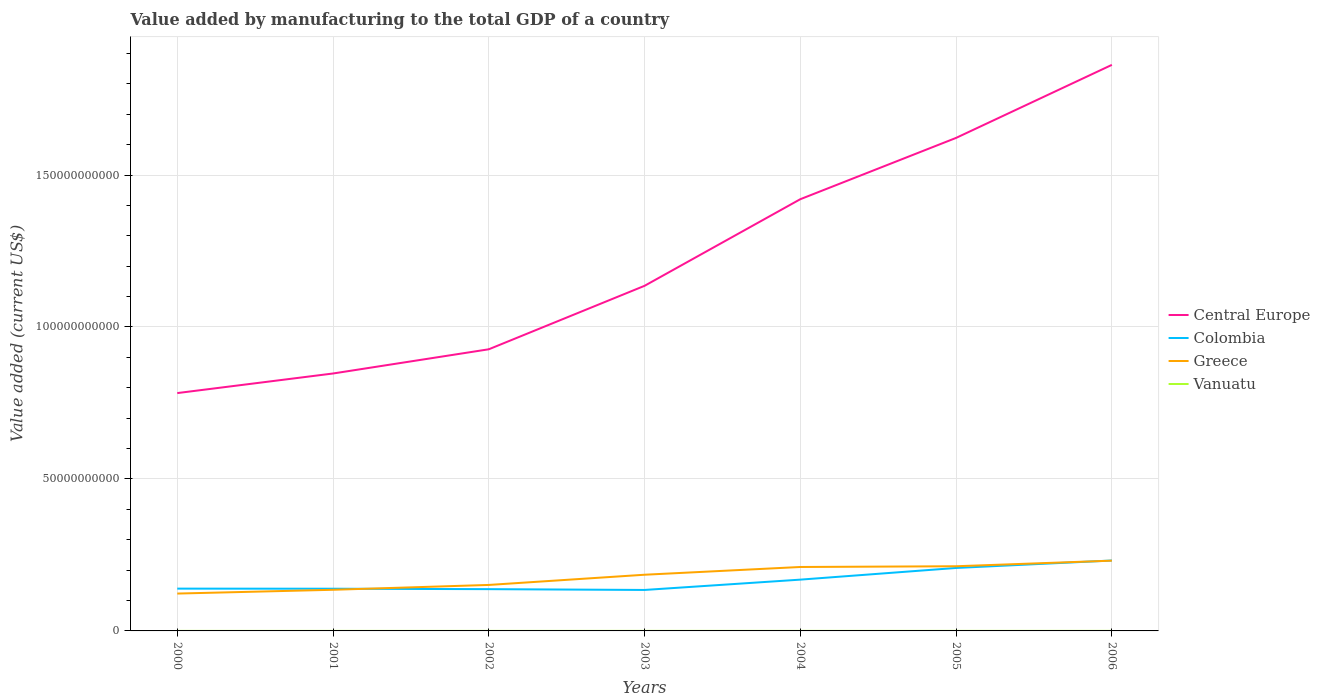How many different coloured lines are there?
Your answer should be very brief. 4. Across all years, what is the maximum value added by manufacturing to the total GDP in Central Europe?
Make the answer very short. 7.82e+1. In which year was the value added by manufacturing to the total GDP in Central Europe maximum?
Ensure brevity in your answer.  2000. What is the total value added by manufacturing to the total GDP in Central Europe in the graph?
Ensure brevity in your answer.  -4.87e+1. What is the difference between the highest and the second highest value added by manufacturing to the total GDP in Vanuatu?
Your response must be concise. 4.83e+06. What is the difference between the highest and the lowest value added by manufacturing to the total GDP in Vanuatu?
Provide a succinct answer. 3. Is the value added by manufacturing to the total GDP in Greece strictly greater than the value added by manufacturing to the total GDP in Central Europe over the years?
Your response must be concise. Yes. How many lines are there?
Make the answer very short. 4. Are the values on the major ticks of Y-axis written in scientific E-notation?
Offer a very short reply. No. How many legend labels are there?
Offer a terse response. 4. What is the title of the graph?
Your answer should be compact. Value added by manufacturing to the total GDP of a country. What is the label or title of the X-axis?
Give a very brief answer. Years. What is the label or title of the Y-axis?
Give a very brief answer. Value added (current US$). What is the Value added (current US$) of Central Europe in 2000?
Provide a short and direct response. 7.82e+1. What is the Value added (current US$) of Colombia in 2000?
Ensure brevity in your answer.  1.39e+1. What is the Value added (current US$) in Greece in 2000?
Ensure brevity in your answer.  1.23e+1. What is the Value added (current US$) of Vanuatu in 2000?
Your response must be concise. 1.23e+07. What is the Value added (current US$) of Central Europe in 2001?
Your answer should be very brief. 8.47e+1. What is the Value added (current US$) in Colombia in 2001?
Ensure brevity in your answer.  1.39e+1. What is the Value added (current US$) of Greece in 2001?
Provide a succinct answer. 1.35e+1. What is the Value added (current US$) in Vanuatu in 2001?
Offer a very short reply. 1.16e+07. What is the Value added (current US$) of Central Europe in 2002?
Offer a very short reply. 9.27e+1. What is the Value added (current US$) in Colombia in 2002?
Provide a short and direct response. 1.37e+1. What is the Value added (current US$) of Greece in 2002?
Provide a short and direct response. 1.51e+1. What is the Value added (current US$) of Vanuatu in 2002?
Your answer should be compact. 1.10e+07. What is the Value added (current US$) in Central Europe in 2003?
Your answer should be very brief. 1.14e+11. What is the Value added (current US$) of Colombia in 2003?
Give a very brief answer. 1.35e+1. What is the Value added (current US$) of Greece in 2003?
Your answer should be very brief. 1.85e+1. What is the Value added (current US$) in Vanuatu in 2003?
Provide a succinct answer. 1.29e+07. What is the Value added (current US$) of Central Europe in 2004?
Provide a short and direct response. 1.42e+11. What is the Value added (current US$) in Colombia in 2004?
Provide a succinct answer. 1.69e+1. What is the Value added (current US$) of Greece in 2004?
Offer a terse response. 2.10e+1. What is the Value added (current US$) in Vanuatu in 2004?
Offer a terse response. 1.47e+07. What is the Value added (current US$) of Central Europe in 2005?
Offer a terse response. 1.62e+11. What is the Value added (current US$) in Colombia in 2005?
Your answer should be very brief. 2.07e+1. What is the Value added (current US$) in Greece in 2005?
Provide a short and direct response. 2.13e+1. What is the Value added (current US$) of Vanuatu in 2005?
Offer a very short reply. 1.50e+07. What is the Value added (current US$) of Central Europe in 2006?
Provide a short and direct response. 1.86e+11. What is the Value added (current US$) of Colombia in 2006?
Your answer should be very brief. 2.32e+1. What is the Value added (current US$) of Greece in 2006?
Provide a succinct answer. 2.31e+1. What is the Value added (current US$) in Vanuatu in 2006?
Offer a very short reply. 1.59e+07. Across all years, what is the maximum Value added (current US$) of Central Europe?
Provide a succinct answer. 1.86e+11. Across all years, what is the maximum Value added (current US$) of Colombia?
Provide a short and direct response. 2.32e+1. Across all years, what is the maximum Value added (current US$) of Greece?
Ensure brevity in your answer.  2.31e+1. Across all years, what is the maximum Value added (current US$) in Vanuatu?
Ensure brevity in your answer.  1.59e+07. Across all years, what is the minimum Value added (current US$) in Central Europe?
Your answer should be compact. 7.82e+1. Across all years, what is the minimum Value added (current US$) in Colombia?
Offer a very short reply. 1.35e+1. Across all years, what is the minimum Value added (current US$) of Greece?
Offer a very short reply. 1.23e+1. Across all years, what is the minimum Value added (current US$) in Vanuatu?
Give a very brief answer. 1.10e+07. What is the total Value added (current US$) in Central Europe in the graph?
Make the answer very short. 8.60e+11. What is the total Value added (current US$) in Colombia in the graph?
Your response must be concise. 1.16e+11. What is the total Value added (current US$) in Greece in the graph?
Make the answer very short. 1.25e+11. What is the total Value added (current US$) in Vanuatu in the graph?
Your response must be concise. 9.34e+07. What is the difference between the Value added (current US$) of Central Europe in 2000 and that in 2001?
Your answer should be very brief. -6.45e+09. What is the difference between the Value added (current US$) of Colombia in 2000 and that in 2001?
Offer a terse response. 3.37e+07. What is the difference between the Value added (current US$) of Greece in 2000 and that in 2001?
Make the answer very short. -1.24e+09. What is the difference between the Value added (current US$) in Vanuatu in 2000 and that in 2001?
Make the answer very short. 6.82e+05. What is the difference between the Value added (current US$) in Central Europe in 2000 and that in 2002?
Give a very brief answer. -1.44e+1. What is the difference between the Value added (current US$) of Colombia in 2000 and that in 2002?
Keep it short and to the point. 1.74e+08. What is the difference between the Value added (current US$) in Greece in 2000 and that in 2002?
Provide a succinct answer. -2.84e+09. What is the difference between the Value added (current US$) of Vanuatu in 2000 and that in 2002?
Keep it short and to the point. 1.24e+06. What is the difference between the Value added (current US$) in Central Europe in 2000 and that in 2003?
Your answer should be compact. -3.53e+1. What is the difference between the Value added (current US$) of Colombia in 2000 and that in 2003?
Provide a succinct answer. 4.36e+08. What is the difference between the Value added (current US$) of Greece in 2000 and that in 2003?
Ensure brevity in your answer.  -6.19e+09. What is the difference between the Value added (current US$) in Vanuatu in 2000 and that in 2003?
Give a very brief answer. -6.28e+05. What is the difference between the Value added (current US$) of Central Europe in 2000 and that in 2004?
Your answer should be very brief. -6.38e+1. What is the difference between the Value added (current US$) of Colombia in 2000 and that in 2004?
Provide a short and direct response. -2.96e+09. What is the difference between the Value added (current US$) in Greece in 2000 and that in 2004?
Your answer should be compact. -8.74e+09. What is the difference between the Value added (current US$) in Vanuatu in 2000 and that in 2004?
Your answer should be very brief. -2.45e+06. What is the difference between the Value added (current US$) of Central Europe in 2000 and that in 2005?
Your response must be concise. -8.40e+1. What is the difference between the Value added (current US$) of Colombia in 2000 and that in 2005?
Offer a terse response. -6.80e+09. What is the difference between the Value added (current US$) in Greece in 2000 and that in 2005?
Your answer should be compact. -8.98e+09. What is the difference between the Value added (current US$) in Vanuatu in 2000 and that in 2005?
Your answer should be very brief. -2.72e+06. What is the difference between the Value added (current US$) of Central Europe in 2000 and that in 2006?
Give a very brief answer. -1.08e+11. What is the difference between the Value added (current US$) of Colombia in 2000 and that in 2006?
Provide a succinct answer. -9.25e+09. What is the difference between the Value added (current US$) of Greece in 2000 and that in 2006?
Offer a terse response. -1.08e+1. What is the difference between the Value added (current US$) in Vanuatu in 2000 and that in 2006?
Offer a terse response. -3.59e+06. What is the difference between the Value added (current US$) of Central Europe in 2001 and that in 2002?
Make the answer very short. -7.97e+09. What is the difference between the Value added (current US$) in Colombia in 2001 and that in 2002?
Give a very brief answer. 1.40e+08. What is the difference between the Value added (current US$) of Greece in 2001 and that in 2002?
Your answer should be very brief. -1.59e+09. What is the difference between the Value added (current US$) of Vanuatu in 2001 and that in 2002?
Your response must be concise. 5.54e+05. What is the difference between the Value added (current US$) in Central Europe in 2001 and that in 2003?
Provide a short and direct response. -2.88e+1. What is the difference between the Value added (current US$) of Colombia in 2001 and that in 2003?
Your answer should be compact. 4.03e+08. What is the difference between the Value added (current US$) of Greece in 2001 and that in 2003?
Provide a short and direct response. -4.95e+09. What is the difference between the Value added (current US$) of Vanuatu in 2001 and that in 2003?
Ensure brevity in your answer.  -1.31e+06. What is the difference between the Value added (current US$) in Central Europe in 2001 and that in 2004?
Offer a terse response. -5.73e+1. What is the difference between the Value added (current US$) in Colombia in 2001 and that in 2004?
Make the answer very short. -2.99e+09. What is the difference between the Value added (current US$) of Greece in 2001 and that in 2004?
Provide a short and direct response. -7.50e+09. What is the difference between the Value added (current US$) in Vanuatu in 2001 and that in 2004?
Offer a very short reply. -3.13e+06. What is the difference between the Value added (current US$) in Central Europe in 2001 and that in 2005?
Your answer should be very brief. -7.75e+1. What is the difference between the Value added (current US$) of Colombia in 2001 and that in 2005?
Provide a short and direct response. -6.83e+09. What is the difference between the Value added (current US$) of Greece in 2001 and that in 2005?
Your response must be concise. -7.74e+09. What is the difference between the Value added (current US$) in Vanuatu in 2001 and that in 2005?
Offer a terse response. -3.41e+06. What is the difference between the Value added (current US$) of Central Europe in 2001 and that in 2006?
Offer a terse response. -1.02e+11. What is the difference between the Value added (current US$) of Colombia in 2001 and that in 2006?
Provide a short and direct response. -9.29e+09. What is the difference between the Value added (current US$) in Greece in 2001 and that in 2006?
Offer a terse response. -9.58e+09. What is the difference between the Value added (current US$) in Vanuatu in 2001 and that in 2006?
Your response must be concise. -4.28e+06. What is the difference between the Value added (current US$) of Central Europe in 2002 and that in 2003?
Offer a very short reply. -2.09e+1. What is the difference between the Value added (current US$) of Colombia in 2002 and that in 2003?
Your response must be concise. 2.62e+08. What is the difference between the Value added (current US$) in Greece in 2002 and that in 2003?
Ensure brevity in your answer.  -3.36e+09. What is the difference between the Value added (current US$) in Vanuatu in 2002 and that in 2003?
Your answer should be very brief. -1.86e+06. What is the difference between the Value added (current US$) of Central Europe in 2002 and that in 2004?
Give a very brief answer. -4.94e+1. What is the difference between the Value added (current US$) of Colombia in 2002 and that in 2004?
Offer a very short reply. -3.13e+09. What is the difference between the Value added (current US$) of Greece in 2002 and that in 2004?
Offer a very short reply. -5.91e+09. What is the difference between the Value added (current US$) in Vanuatu in 2002 and that in 2004?
Provide a short and direct response. -3.68e+06. What is the difference between the Value added (current US$) of Central Europe in 2002 and that in 2005?
Keep it short and to the point. -6.95e+1. What is the difference between the Value added (current US$) of Colombia in 2002 and that in 2005?
Make the answer very short. -6.97e+09. What is the difference between the Value added (current US$) of Greece in 2002 and that in 2005?
Your answer should be very brief. -6.15e+09. What is the difference between the Value added (current US$) of Vanuatu in 2002 and that in 2005?
Offer a terse response. -3.96e+06. What is the difference between the Value added (current US$) of Central Europe in 2002 and that in 2006?
Your answer should be very brief. -9.36e+1. What is the difference between the Value added (current US$) in Colombia in 2002 and that in 2006?
Keep it short and to the point. -9.43e+09. What is the difference between the Value added (current US$) in Greece in 2002 and that in 2006?
Offer a very short reply. -7.99e+09. What is the difference between the Value added (current US$) of Vanuatu in 2002 and that in 2006?
Offer a terse response. -4.83e+06. What is the difference between the Value added (current US$) of Central Europe in 2003 and that in 2004?
Give a very brief answer. -2.85e+1. What is the difference between the Value added (current US$) of Colombia in 2003 and that in 2004?
Your answer should be very brief. -3.39e+09. What is the difference between the Value added (current US$) of Greece in 2003 and that in 2004?
Keep it short and to the point. -2.55e+09. What is the difference between the Value added (current US$) in Vanuatu in 2003 and that in 2004?
Your response must be concise. -1.82e+06. What is the difference between the Value added (current US$) in Central Europe in 2003 and that in 2005?
Offer a very short reply. -4.87e+1. What is the difference between the Value added (current US$) of Colombia in 2003 and that in 2005?
Your answer should be compact. -7.24e+09. What is the difference between the Value added (current US$) in Greece in 2003 and that in 2005?
Provide a short and direct response. -2.79e+09. What is the difference between the Value added (current US$) of Vanuatu in 2003 and that in 2005?
Your answer should be compact. -2.10e+06. What is the difference between the Value added (current US$) of Central Europe in 2003 and that in 2006?
Your response must be concise. -7.27e+1. What is the difference between the Value added (current US$) of Colombia in 2003 and that in 2006?
Offer a very short reply. -9.69e+09. What is the difference between the Value added (current US$) of Greece in 2003 and that in 2006?
Your answer should be compact. -4.63e+09. What is the difference between the Value added (current US$) of Vanuatu in 2003 and that in 2006?
Make the answer very short. -2.96e+06. What is the difference between the Value added (current US$) in Central Europe in 2004 and that in 2005?
Give a very brief answer. -2.02e+1. What is the difference between the Value added (current US$) in Colombia in 2004 and that in 2005?
Ensure brevity in your answer.  -3.84e+09. What is the difference between the Value added (current US$) of Greece in 2004 and that in 2005?
Ensure brevity in your answer.  -2.39e+08. What is the difference between the Value added (current US$) in Vanuatu in 2004 and that in 2005?
Provide a succinct answer. -2.79e+05. What is the difference between the Value added (current US$) of Central Europe in 2004 and that in 2006?
Offer a terse response. -4.42e+1. What is the difference between the Value added (current US$) of Colombia in 2004 and that in 2006?
Offer a very short reply. -6.29e+09. What is the difference between the Value added (current US$) of Greece in 2004 and that in 2006?
Your response must be concise. -2.08e+09. What is the difference between the Value added (current US$) of Vanuatu in 2004 and that in 2006?
Provide a succinct answer. -1.15e+06. What is the difference between the Value added (current US$) of Central Europe in 2005 and that in 2006?
Make the answer very short. -2.40e+1. What is the difference between the Value added (current US$) in Colombia in 2005 and that in 2006?
Offer a very short reply. -2.45e+09. What is the difference between the Value added (current US$) in Greece in 2005 and that in 2006?
Offer a terse response. -1.84e+09. What is the difference between the Value added (current US$) in Vanuatu in 2005 and that in 2006?
Give a very brief answer. -8.68e+05. What is the difference between the Value added (current US$) of Central Europe in 2000 and the Value added (current US$) of Colombia in 2001?
Make the answer very short. 6.44e+1. What is the difference between the Value added (current US$) in Central Europe in 2000 and the Value added (current US$) in Greece in 2001?
Ensure brevity in your answer.  6.47e+1. What is the difference between the Value added (current US$) of Central Europe in 2000 and the Value added (current US$) of Vanuatu in 2001?
Make the answer very short. 7.82e+1. What is the difference between the Value added (current US$) of Colombia in 2000 and the Value added (current US$) of Greece in 2001?
Make the answer very short. 3.81e+08. What is the difference between the Value added (current US$) of Colombia in 2000 and the Value added (current US$) of Vanuatu in 2001?
Provide a short and direct response. 1.39e+1. What is the difference between the Value added (current US$) of Greece in 2000 and the Value added (current US$) of Vanuatu in 2001?
Make the answer very short. 1.23e+1. What is the difference between the Value added (current US$) in Central Europe in 2000 and the Value added (current US$) in Colombia in 2002?
Offer a very short reply. 6.45e+1. What is the difference between the Value added (current US$) in Central Europe in 2000 and the Value added (current US$) in Greece in 2002?
Your answer should be very brief. 6.31e+1. What is the difference between the Value added (current US$) of Central Europe in 2000 and the Value added (current US$) of Vanuatu in 2002?
Your answer should be very brief. 7.82e+1. What is the difference between the Value added (current US$) of Colombia in 2000 and the Value added (current US$) of Greece in 2002?
Keep it short and to the point. -1.21e+09. What is the difference between the Value added (current US$) of Colombia in 2000 and the Value added (current US$) of Vanuatu in 2002?
Your answer should be compact. 1.39e+1. What is the difference between the Value added (current US$) in Greece in 2000 and the Value added (current US$) in Vanuatu in 2002?
Your answer should be compact. 1.23e+1. What is the difference between the Value added (current US$) in Central Europe in 2000 and the Value added (current US$) in Colombia in 2003?
Your answer should be very brief. 6.48e+1. What is the difference between the Value added (current US$) of Central Europe in 2000 and the Value added (current US$) of Greece in 2003?
Give a very brief answer. 5.98e+1. What is the difference between the Value added (current US$) in Central Europe in 2000 and the Value added (current US$) in Vanuatu in 2003?
Your answer should be compact. 7.82e+1. What is the difference between the Value added (current US$) of Colombia in 2000 and the Value added (current US$) of Greece in 2003?
Offer a terse response. -4.57e+09. What is the difference between the Value added (current US$) of Colombia in 2000 and the Value added (current US$) of Vanuatu in 2003?
Your answer should be compact. 1.39e+1. What is the difference between the Value added (current US$) in Greece in 2000 and the Value added (current US$) in Vanuatu in 2003?
Your response must be concise. 1.23e+1. What is the difference between the Value added (current US$) in Central Europe in 2000 and the Value added (current US$) in Colombia in 2004?
Make the answer very short. 6.14e+1. What is the difference between the Value added (current US$) in Central Europe in 2000 and the Value added (current US$) in Greece in 2004?
Provide a succinct answer. 5.72e+1. What is the difference between the Value added (current US$) of Central Europe in 2000 and the Value added (current US$) of Vanuatu in 2004?
Give a very brief answer. 7.82e+1. What is the difference between the Value added (current US$) of Colombia in 2000 and the Value added (current US$) of Greece in 2004?
Ensure brevity in your answer.  -7.12e+09. What is the difference between the Value added (current US$) of Colombia in 2000 and the Value added (current US$) of Vanuatu in 2004?
Your answer should be compact. 1.39e+1. What is the difference between the Value added (current US$) of Greece in 2000 and the Value added (current US$) of Vanuatu in 2004?
Offer a very short reply. 1.23e+1. What is the difference between the Value added (current US$) of Central Europe in 2000 and the Value added (current US$) of Colombia in 2005?
Your response must be concise. 5.75e+1. What is the difference between the Value added (current US$) in Central Europe in 2000 and the Value added (current US$) in Greece in 2005?
Keep it short and to the point. 5.70e+1. What is the difference between the Value added (current US$) of Central Europe in 2000 and the Value added (current US$) of Vanuatu in 2005?
Ensure brevity in your answer.  7.82e+1. What is the difference between the Value added (current US$) of Colombia in 2000 and the Value added (current US$) of Greece in 2005?
Keep it short and to the point. -7.36e+09. What is the difference between the Value added (current US$) of Colombia in 2000 and the Value added (current US$) of Vanuatu in 2005?
Ensure brevity in your answer.  1.39e+1. What is the difference between the Value added (current US$) of Greece in 2000 and the Value added (current US$) of Vanuatu in 2005?
Provide a succinct answer. 1.23e+1. What is the difference between the Value added (current US$) in Central Europe in 2000 and the Value added (current US$) in Colombia in 2006?
Offer a very short reply. 5.51e+1. What is the difference between the Value added (current US$) of Central Europe in 2000 and the Value added (current US$) of Greece in 2006?
Keep it short and to the point. 5.51e+1. What is the difference between the Value added (current US$) of Central Europe in 2000 and the Value added (current US$) of Vanuatu in 2006?
Give a very brief answer. 7.82e+1. What is the difference between the Value added (current US$) of Colombia in 2000 and the Value added (current US$) of Greece in 2006?
Your answer should be compact. -9.20e+09. What is the difference between the Value added (current US$) of Colombia in 2000 and the Value added (current US$) of Vanuatu in 2006?
Keep it short and to the point. 1.39e+1. What is the difference between the Value added (current US$) of Greece in 2000 and the Value added (current US$) of Vanuatu in 2006?
Your response must be concise. 1.23e+1. What is the difference between the Value added (current US$) in Central Europe in 2001 and the Value added (current US$) in Colombia in 2002?
Give a very brief answer. 7.10e+1. What is the difference between the Value added (current US$) of Central Europe in 2001 and the Value added (current US$) of Greece in 2002?
Keep it short and to the point. 6.96e+1. What is the difference between the Value added (current US$) in Central Europe in 2001 and the Value added (current US$) in Vanuatu in 2002?
Keep it short and to the point. 8.47e+1. What is the difference between the Value added (current US$) of Colombia in 2001 and the Value added (current US$) of Greece in 2002?
Your answer should be compact. -1.25e+09. What is the difference between the Value added (current US$) in Colombia in 2001 and the Value added (current US$) in Vanuatu in 2002?
Provide a succinct answer. 1.39e+1. What is the difference between the Value added (current US$) of Greece in 2001 and the Value added (current US$) of Vanuatu in 2002?
Provide a succinct answer. 1.35e+1. What is the difference between the Value added (current US$) in Central Europe in 2001 and the Value added (current US$) in Colombia in 2003?
Your response must be concise. 7.12e+1. What is the difference between the Value added (current US$) in Central Europe in 2001 and the Value added (current US$) in Greece in 2003?
Your response must be concise. 6.62e+1. What is the difference between the Value added (current US$) of Central Europe in 2001 and the Value added (current US$) of Vanuatu in 2003?
Offer a terse response. 8.47e+1. What is the difference between the Value added (current US$) of Colombia in 2001 and the Value added (current US$) of Greece in 2003?
Provide a succinct answer. -4.60e+09. What is the difference between the Value added (current US$) in Colombia in 2001 and the Value added (current US$) in Vanuatu in 2003?
Your response must be concise. 1.39e+1. What is the difference between the Value added (current US$) in Greece in 2001 and the Value added (current US$) in Vanuatu in 2003?
Your answer should be very brief. 1.35e+1. What is the difference between the Value added (current US$) in Central Europe in 2001 and the Value added (current US$) in Colombia in 2004?
Keep it short and to the point. 6.78e+1. What is the difference between the Value added (current US$) in Central Europe in 2001 and the Value added (current US$) in Greece in 2004?
Give a very brief answer. 6.37e+1. What is the difference between the Value added (current US$) of Central Europe in 2001 and the Value added (current US$) of Vanuatu in 2004?
Provide a succinct answer. 8.47e+1. What is the difference between the Value added (current US$) in Colombia in 2001 and the Value added (current US$) in Greece in 2004?
Your answer should be very brief. -7.15e+09. What is the difference between the Value added (current US$) of Colombia in 2001 and the Value added (current US$) of Vanuatu in 2004?
Ensure brevity in your answer.  1.39e+1. What is the difference between the Value added (current US$) of Greece in 2001 and the Value added (current US$) of Vanuatu in 2004?
Give a very brief answer. 1.35e+1. What is the difference between the Value added (current US$) in Central Europe in 2001 and the Value added (current US$) in Colombia in 2005?
Offer a very short reply. 6.40e+1. What is the difference between the Value added (current US$) of Central Europe in 2001 and the Value added (current US$) of Greece in 2005?
Ensure brevity in your answer.  6.34e+1. What is the difference between the Value added (current US$) of Central Europe in 2001 and the Value added (current US$) of Vanuatu in 2005?
Give a very brief answer. 8.47e+1. What is the difference between the Value added (current US$) in Colombia in 2001 and the Value added (current US$) in Greece in 2005?
Provide a short and direct response. -7.39e+09. What is the difference between the Value added (current US$) of Colombia in 2001 and the Value added (current US$) of Vanuatu in 2005?
Offer a terse response. 1.39e+1. What is the difference between the Value added (current US$) in Greece in 2001 and the Value added (current US$) in Vanuatu in 2005?
Offer a terse response. 1.35e+1. What is the difference between the Value added (current US$) in Central Europe in 2001 and the Value added (current US$) in Colombia in 2006?
Your answer should be compact. 6.15e+1. What is the difference between the Value added (current US$) of Central Europe in 2001 and the Value added (current US$) of Greece in 2006?
Your answer should be compact. 6.16e+1. What is the difference between the Value added (current US$) of Central Europe in 2001 and the Value added (current US$) of Vanuatu in 2006?
Give a very brief answer. 8.47e+1. What is the difference between the Value added (current US$) in Colombia in 2001 and the Value added (current US$) in Greece in 2006?
Offer a very short reply. -9.23e+09. What is the difference between the Value added (current US$) of Colombia in 2001 and the Value added (current US$) of Vanuatu in 2006?
Give a very brief answer. 1.39e+1. What is the difference between the Value added (current US$) in Greece in 2001 and the Value added (current US$) in Vanuatu in 2006?
Ensure brevity in your answer.  1.35e+1. What is the difference between the Value added (current US$) in Central Europe in 2002 and the Value added (current US$) in Colombia in 2003?
Your response must be concise. 7.92e+1. What is the difference between the Value added (current US$) of Central Europe in 2002 and the Value added (current US$) of Greece in 2003?
Your answer should be compact. 7.42e+1. What is the difference between the Value added (current US$) of Central Europe in 2002 and the Value added (current US$) of Vanuatu in 2003?
Keep it short and to the point. 9.26e+1. What is the difference between the Value added (current US$) of Colombia in 2002 and the Value added (current US$) of Greece in 2003?
Make the answer very short. -4.74e+09. What is the difference between the Value added (current US$) of Colombia in 2002 and the Value added (current US$) of Vanuatu in 2003?
Your response must be concise. 1.37e+1. What is the difference between the Value added (current US$) of Greece in 2002 and the Value added (current US$) of Vanuatu in 2003?
Keep it short and to the point. 1.51e+1. What is the difference between the Value added (current US$) in Central Europe in 2002 and the Value added (current US$) in Colombia in 2004?
Offer a very short reply. 7.58e+1. What is the difference between the Value added (current US$) of Central Europe in 2002 and the Value added (current US$) of Greece in 2004?
Your response must be concise. 7.16e+1. What is the difference between the Value added (current US$) in Central Europe in 2002 and the Value added (current US$) in Vanuatu in 2004?
Keep it short and to the point. 9.26e+1. What is the difference between the Value added (current US$) in Colombia in 2002 and the Value added (current US$) in Greece in 2004?
Offer a terse response. -7.29e+09. What is the difference between the Value added (current US$) in Colombia in 2002 and the Value added (current US$) in Vanuatu in 2004?
Provide a short and direct response. 1.37e+1. What is the difference between the Value added (current US$) in Greece in 2002 and the Value added (current US$) in Vanuatu in 2004?
Make the answer very short. 1.51e+1. What is the difference between the Value added (current US$) in Central Europe in 2002 and the Value added (current US$) in Colombia in 2005?
Make the answer very short. 7.19e+1. What is the difference between the Value added (current US$) of Central Europe in 2002 and the Value added (current US$) of Greece in 2005?
Make the answer very short. 7.14e+1. What is the difference between the Value added (current US$) of Central Europe in 2002 and the Value added (current US$) of Vanuatu in 2005?
Your answer should be very brief. 9.26e+1. What is the difference between the Value added (current US$) of Colombia in 2002 and the Value added (current US$) of Greece in 2005?
Offer a terse response. -7.53e+09. What is the difference between the Value added (current US$) of Colombia in 2002 and the Value added (current US$) of Vanuatu in 2005?
Provide a succinct answer. 1.37e+1. What is the difference between the Value added (current US$) in Greece in 2002 and the Value added (current US$) in Vanuatu in 2005?
Offer a terse response. 1.51e+1. What is the difference between the Value added (current US$) in Central Europe in 2002 and the Value added (current US$) in Colombia in 2006?
Make the answer very short. 6.95e+1. What is the difference between the Value added (current US$) of Central Europe in 2002 and the Value added (current US$) of Greece in 2006?
Give a very brief answer. 6.95e+1. What is the difference between the Value added (current US$) of Central Europe in 2002 and the Value added (current US$) of Vanuatu in 2006?
Give a very brief answer. 9.26e+1. What is the difference between the Value added (current US$) of Colombia in 2002 and the Value added (current US$) of Greece in 2006?
Provide a short and direct response. -9.37e+09. What is the difference between the Value added (current US$) in Colombia in 2002 and the Value added (current US$) in Vanuatu in 2006?
Ensure brevity in your answer.  1.37e+1. What is the difference between the Value added (current US$) of Greece in 2002 and the Value added (current US$) of Vanuatu in 2006?
Offer a terse response. 1.51e+1. What is the difference between the Value added (current US$) of Central Europe in 2003 and the Value added (current US$) of Colombia in 2004?
Make the answer very short. 9.67e+1. What is the difference between the Value added (current US$) of Central Europe in 2003 and the Value added (current US$) of Greece in 2004?
Your response must be concise. 9.25e+1. What is the difference between the Value added (current US$) of Central Europe in 2003 and the Value added (current US$) of Vanuatu in 2004?
Give a very brief answer. 1.14e+11. What is the difference between the Value added (current US$) of Colombia in 2003 and the Value added (current US$) of Greece in 2004?
Your answer should be compact. -7.56e+09. What is the difference between the Value added (current US$) in Colombia in 2003 and the Value added (current US$) in Vanuatu in 2004?
Provide a succinct answer. 1.35e+1. What is the difference between the Value added (current US$) of Greece in 2003 and the Value added (current US$) of Vanuatu in 2004?
Provide a succinct answer. 1.85e+1. What is the difference between the Value added (current US$) of Central Europe in 2003 and the Value added (current US$) of Colombia in 2005?
Keep it short and to the point. 9.28e+1. What is the difference between the Value added (current US$) in Central Europe in 2003 and the Value added (current US$) in Greece in 2005?
Give a very brief answer. 9.23e+1. What is the difference between the Value added (current US$) in Central Europe in 2003 and the Value added (current US$) in Vanuatu in 2005?
Your answer should be compact. 1.14e+11. What is the difference between the Value added (current US$) of Colombia in 2003 and the Value added (current US$) of Greece in 2005?
Provide a succinct answer. -7.80e+09. What is the difference between the Value added (current US$) of Colombia in 2003 and the Value added (current US$) of Vanuatu in 2005?
Your answer should be compact. 1.35e+1. What is the difference between the Value added (current US$) in Greece in 2003 and the Value added (current US$) in Vanuatu in 2005?
Your response must be concise. 1.85e+1. What is the difference between the Value added (current US$) of Central Europe in 2003 and the Value added (current US$) of Colombia in 2006?
Your answer should be compact. 9.04e+1. What is the difference between the Value added (current US$) of Central Europe in 2003 and the Value added (current US$) of Greece in 2006?
Provide a succinct answer. 9.04e+1. What is the difference between the Value added (current US$) of Central Europe in 2003 and the Value added (current US$) of Vanuatu in 2006?
Provide a succinct answer. 1.14e+11. What is the difference between the Value added (current US$) in Colombia in 2003 and the Value added (current US$) in Greece in 2006?
Provide a succinct answer. -9.64e+09. What is the difference between the Value added (current US$) in Colombia in 2003 and the Value added (current US$) in Vanuatu in 2006?
Your answer should be very brief. 1.35e+1. What is the difference between the Value added (current US$) of Greece in 2003 and the Value added (current US$) of Vanuatu in 2006?
Your answer should be compact. 1.85e+1. What is the difference between the Value added (current US$) in Central Europe in 2004 and the Value added (current US$) in Colombia in 2005?
Offer a very short reply. 1.21e+11. What is the difference between the Value added (current US$) in Central Europe in 2004 and the Value added (current US$) in Greece in 2005?
Keep it short and to the point. 1.21e+11. What is the difference between the Value added (current US$) in Central Europe in 2004 and the Value added (current US$) in Vanuatu in 2005?
Your answer should be very brief. 1.42e+11. What is the difference between the Value added (current US$) of Colombia in 2004 and the Value added (current US$) of Greece in 2005?
Give a very brief answer. -4.40e+09. What is the difference between the Value added (current US$) of Colombia in 2004 and the Value added (current US$) of Vanuatu in 2005?
Provide a succinct answer. 1.69e+1. What is the difference between the Value added (current US$) of Greece in 2004 and the Value added (current US$) of Vanuatu in 2005?
Provide a short and direct response. 2.10e+1. What is the difference between the Value added (current US$) of Central Europe in 2004 and the Value added (current US$) of Colombia in 2006?
Offer a terse response. 1.19e+11. What is the difference between the Value added (current US$) of Central Europe in 2004 and the Value added (current US$) of Greece in 2006?
Ensure brevity in your answer.  1.19e+11. What is the difference between the Value added (current US$) in Central Europe in 2004 and the Value added (current US$) in Vanuatu in 2006?
Keep it short and to the point. 1.42e+11. What is the difference between the Value added (current US$) of Colombia in 2004 and the Value added (current US$) of Greece in 2006?
Offer a terse response. -6.24e+09. What is the difference between the Value added (current US$) in Colombia in 2004 and the Value added (current US$) in Vanuatu in 2006?
Your answer should be compact. 1.69e+1. What is the difference between the Value added (current US$) of Greece in 2004 and the Value added (current US$) of Vanuatu in 2006?
Ensure brevity in your answer.  2.10e+1. What is the difference between the Value added (current US$) of Central Europe in 2005 and the Value added (current US$) of Colombia in 2006?
Your answer should be compact. 1.39e+11. What is the difference between the Value added (current US$) in Central Europe in 2005 and the Value added (current US$) in Greece in 2006?
Offer a very short reply. 1.39e+11. What is the difference between the Value added (current US$) in Central Europe in 2005 and the Value added (current US$) in Vanuatu in 2006?
Your response must be concise. 1.62e+11. What is the difference between the Value added (current US$) in Colombia in 2005 and the Value added (current US$) in Greece in 2006?
Your response must be concise. -2.40e+09. What is the difference between the Value added (current US$) in Colombia in 2005 and the Value added (current US$) in Vanuatu in 2006?
Your answer should be very brief. 2.07e+1. What is the difference between the Value added (current US$) in Greece in 2005 and the Value added (current US$) in Vanuatu in 2006?
Your answer should be compact. 2.13e+1. What is the average Value added (current US$) of Central Europe per year?
Provide a succinct answer. 1.23e+11. What is the average Value added (current US$) of Colombia per year?
Your answer should be compact. 1.65e+1. What is the average Value added (current US$) in Greece per year?
Offer a terse response. 1.78e+1. What is the average Value added (current US$) of Vanuatu per year?
Provide a short and direct response. 1.33e+07. In the year 2000, what is the difference between the Value added (current US$) of Central Europe and Value added (current US$) of Colombia?
Provide a short and direct response. 6.43e+1. In the year 2000, what is the difference between the Value added (current US$) in Central Europe and Value added (current US$) in Greece?
Keep it short and to the point. 6.60e+1. In the year 2000, what is the difference between the Value added (current US$) of Central Europe and Value added (current US$) of Vanuatu?
Ensure brevity in your answer.  7.82e+1. In the year 2000, what is the difference between the Value added (current US$) of Colombia and Value added (current US$) of Greece?
Your answer should be compact. 1.62e+09. In the year 2000, what is the difference between the Value added (current US$) of Colombia and Value added (current US$) of Vanuatu?
Provide a succinct answer. 1.39e+1. In the year 2000, what is the difference between the Value added (current US$) of Greece and Value added (current US$) of Vanuatu?
Offer a terse response. 1.23e+1. In the year 2001, what is the difference between the Value added (current US$) in Central Europe and Value added (current US$) in Colombia?
Give a very brief answer. 7.08e+1. In the year 2001, what is the difference between the Value added (current US$) of Central Europe and Value added (current US$) of Greece?
Keep it short and to the point. 7.12e+1. In the year 2001, what is the difference between the Value added (current US$) in Central Europe and Value added (current US$) in Vanuatu?
Make the answer very short. 8.47e+1. In the year 2001, what is the difference between the Value added (current US$) of Colombia and Value added (current US$) of Greece?
Keep it short and to the point. 3.47e+08. In the year 2001, what is the difference between the Value added (current US$) in Colombia and Value added (current US$) in Vanuatu?
Keep it short and to the point. 1.39e+1. In the year 2001, what is the difference between the Value added (current US$) of Greece and Value added (current US$) of Vanuatu?
Give a very brief answer. 1.35e+1. In the year 2002, what is the difference between the Value added (current US$) of Central Europe and Value added (current US$) of Colombia?
Provide a short and direct response. 7.89e+1. In the year 2002, what is the difference between the Value added (current US$) of Central Europe and Value added (current US$) of Greece?
Make the answer very short. 7.75e+1. In the year 2002, what is the difference between the Value added (current US$) of Central Europe and Value added (current US$) of Vanuatu?
Your answer should be compact. 9.27e+1. In the year 2002, what is the difference between the Value added (current US$) in Colombia and Value added (current US$) in Greece?
Keep it short and to the point. -1.39e+09. In the year 2002, what is the difference between the Value added (current US$) of Colombia and Value added (current US$) of Vanuatu?
Ensure brevity in your answer.  1.37e+1. In the year 2002, what is the difference between the Value added (current US$) in Greece and Value added (current US$) in Vanuatu?
Provide a succinct answer. 1.51e+1. In the year 2003, what is the difference between the Value added (current US$) of Central Europe and Value added (current US$) of Colombia?
Make the answer very short. 1.00e+11. In the year 2003, what is the difference between the Value added (current US$) in Central Europe and Value added (current US$) in Greece?
Give a very brief answer. 9.51e+1. In the year 2003, what is the difference between the Value added (current US$) of Central Europe and Value added (current US$) of Vanuatu?
Keep it short and to the point. 1.14e+11. In the year 2003, what is the difference between the Value added (current US$) in Colombia and Value added (current US$) in Greece?
Your answer should be very brief. -5.01e+09. In the year 2003, what is the difference between the Value added (current US$) of Colombia and Value added (current US$) of Vanuatu?
Give a very brief answer. 1.35e+1. In the year 2003, what is the difference between the Value added (current US$) of Greece and Value added (current US$) of Vanuatu?
Keep it short and to the point. 1.85e+1. In the year 2004, what is the difference between the Value added (current US$) of Central Europe and Value added (current US$) of Colombia?
Your answer should be compact. 1.25e+11. In the year 2004, what is the difference between the Value added (current US$) in Central Europe and Value added (current US$) in Greece?
Your response must be concise. 1.21e+11. In the year 2004, what is the difference between the Value added (current US$) in Central Europe and Value added (current US$) in Vanuatu?
Keep it short and to the point. 1.42e+11. In the year 2004, what is the difference between the Value added (current US$) of Colombia and Value added (current US$) of Greece?
Your answer should be compact. -4.16e+09. In the year 2004, what is the difference between the Value added (current US$) of Colombia and Value added (current US$) of Vanuatu?
Your answer should be very brief. 1.69e+1. In the year 2004, what is the difference between the Value added (current US$) in Greece and Value added (current US$) in Vanuatu?
Keep it short and to the point. 2.10e+1. In the year 2005, what is the difference between the Value added (current US$) in Central Europe and Value added (current US$) in Colombia?
Offer a very short reply. 1.41e+11. In the year 2005, what is the difference between the Value added (current US$) in Central Europe and Value added (current US$) in Greece?
Your answer should be very brief. 1.41e+11. In the year 2005, what is the difference between the Value added (current US$) in Central Europe and Value added (current US$) in Vanuatu?
Offer a very short reply. 1.62e+11. In the year 2005, what is the difference between the Value added (current US$) in Colombia and Value added (current US$) in Greece?
Offer a terse response. -5.58e+08. In the year 2005, what is the difference between the Value added (current US$) of Colombia and Value added (current US$) of Vanuatu?
Provide a short and direct response. 2.07e+1. In the year 2005, what is the difference between the Value added (current US$) of Greece and Value added (current US$) of Vanuatu?
Provide a succinct answer. 2.13e+1. In the year 2006, what is the difference between the Value added (current US$) of Central Europe and Value added (current US$) of Colombia?
Your response must be concise. 1.63e+11. In the year 2006, what is the difference between the Value added (current US$) of Central Europe and Value added (current US$) of Greece?
Keep it short and to the point. 1.63e+11. In the year 2006, what is the difference between the Value added (current US$) in Central Europe and Value added (current US$) in Vanuatu?
Your answer should be very brief. 1.86e+11. In the year 2006, what is the difference between the Value added (current US$) in Colombia and Value added (current US$) in Greece?
Your answer should be compact. 5.15e+07. In the year 2006, what is the difference between the Value added (current US$) in Colombia and Value added (current US$) in Vanuatu?
Provide a short and direct response. 2.32e+1. In the year 2006, what is the difference between the Value added (current US$) of Greece and Value added (current US$) of Vanuatu?
Keep it short and to the point. 2.31e+1. What is the ratio of the Value added (current US$) in Central Europe in 2000 to that in 2001?
Offer a terse response. 0.92. What is the ratio of the Value added (current US$) of Greece in 2000 to that in 2001?
Your response must be concise. 0.91. What is the ratio of the Value added (current US$) of Vanuatu in 2000 to that in 2001?
Give a very brief answer. 1.06. What is the ratio of the Value added (current US$) in Central Europe in 2000 to that in 2002?
Offer a very short reply. 0.84. What is the ratio of the Value added (current US$) of Colombia in 2000 to that in 2002?
Give a very brief answer. 1.01. What is the ratio of the Value added (current US$) in Greece in 2000 to that in 2002?
Make the answer very short. 0.81. What is the ratio of the Value added (current US$) of Vanuatu in 2000 to that in 2002?
Ensure brevity in your answer.  1.11. What is the ratio of the Value added (current US$) in Central Europe in 2000 to that in 2003?
Provide a succinct answer. 0.69. What is the ratio of the Value added (current US$) of Colombia in 2000 to that in 2003?
Give a very brief answer. 1.03. What is the ratio of the Value added (current US$) in Greece in 2000 to that in 2003?
Make the answer very short. 0.66. What is the ratio of the Value added (current US$) in Vanuatu in 2000 to that in 2003?
Offer a terse response. 0.95. What is the ratio of the Value added (current US$) in Central Europe in 2000 to that in 2004?
Ensure brevity in your answer.  0.55. What is the ratio of the Value added (current US$) of Colombia in 2000 to that in 2004?
Make the answer very short. 0.82. What is the ratio of the Value added (current US$) in Greece in 2000 to that in 2004?
Provide a succinct answer. 0.58. What is the ratio of the Value added (current US$) of Vanuatu in 2000 to that in 2004?
Your response must be concise. 0.83. What is the ratio of the Value added (current US$) of Central Europe in 2000 to that in 2005?
Provide a succinct answer. 0.48. What is the ratio of the Value added (current US$) of Colombia in 2000 to that in 2005?
Provide a succinct answer. 0.67. What is the ratio of the Value added (current US$) of Greece in 2000 to that in 2005?
Offer a terse response. 0.58. What is the ratio of the Value added (current US$) of Vanuatu in 2000 to that in 2005?
Make the answer very short. 0.82. What is the ratio of the Value added (current US$) of Central Europe in 2000 to that in 2006?
Provide a succinct answer. 0.42. What is the ratio of the Value added (current US$) in Colombia in 2000 to that in 2006?
Provide a short and direct response. 0.6. What is the ratio of the Value added (current US$) of Greece in 2000 to that in 2006?
Keep it short and to the point. 0.53. What is the ratio of the Value added (current US$) in Vanuatu in 2000 to that in 2006?
Ensure brevity in your answer.  0.77. What is the ratio of the Value added (current US$) of Central Europe in 2001 to that in 2002?
Keep it short and to the point. 0.91. What is the ratio of the Value added (current US$) of Colombia in 2001 to that in 2002?
Keep it short and to the point. 1.01. What is the ratio of the Value added (current US$) of Greece in 2001 to that in 2002?
Ensure brevity in your answer.  0.89. What is the ratio of the Value added (current US$) in Vanuatu in 2001 to that in 2002?
Ensure brevity in your answer.  1.05. What is the ratio of the Value added (current US$) in Central Europe in 2001 to that in 2003?
Your answer should be compact. 0.75. What is the ratio of the Value added (current US$) of Colombia in 2001 to that in 2003?
Your answer should be very brief. 1.03. What is the ratio of the Value added (current US$) of Greece in 2001 to that in 2003?
Provide a short and direct response. 0.73. What is the ratio of the Value added (current US$) in Vanuatu in 2001 to that in 2003?
Keep it short and to the point. 0.9. What is the ratio of the Value added (current US$) in Central Europe in 2001 to that in 2004?
Provide a succinct answer. 0.6. What is the ratio of the Value added (current US$) in Colombia in 2001 to that in 2004?
Provide a succinct answer. 0.82. What is the ratio of the Value added (current US$) in Greece in 2001 to that in 2004?
Offer a very short reply. 0.64. What is the ratio of the Value added (current US$) in Vanuatu in 2001 to that in 2004?
Offer a terse response. 0.79. What is the ratio of the Value added (current US$) in Central Europe in 2001 to that in 2005?
Offer a very short reply. 0.52. What is the ratio of the Value added (current US$) of Colombia in 2001 to that in 2005?
Keep it short and to the point. 0.67. What is the ratio of the Value added (current US$) in Greece in 2001 to that in 2005?
Offer a very short reply. 0.64. What is the ratio of the Value added (current US$) of Vanuatu in 2001 to that in 2005?
Offer a terse response. 0.77. What is the ratio of the Value added (current US$) in Central Europe in 2001 to that in 2006?
Provide a short and direct response. 0.45. What is the ratio of the Value added (current US$) in Colombia in 2001 to that in 2006?
Offer a terse response. 0.6. What is the ratio of the Value added (current US$) in Greece in 2001 to that in 2006?
Provide a succinct answer. 0.59. What is the ratio of the Value added (current US$) of Vanuatu in 2001 to that in 2006?
Provide a succinct answer. 0.73. What is the ratio of the Value added (current US$) in Central Europe in 2002 to that in 2003?
Offer a terse response. 0.82. What is the ratio of the Value added (current US$) in Colombia in 2002 to that in 2003?
Make the answer very short. 1.02. What is the ratio of the Value added (current US$) of Greece in 2002 to that in 2003?
Make the answer very short. 0.82. What is the ratio of the Value added (current US$) of Vanuatu in 2002 to that in 2003?
Offer a very short reply. 0.86. What is the ratio of the Value added (current US$) of Central Europe in 2002 to that in 2004?
Keep it short and to the point. 0.65. What is the ratio of the Value added (current US$) in Colombia in 2002 to that in 2004?
Provide a succinct answer. 0.81. What is the ratio of the Value added (current US$) in Greece in 2002 to that in 2004?
Offer a terse response. 0.72. What is the ratio of the Value added (current US$) of Vanuatu in 2002 to that in 2004?
Your answer should be very brief. 0.75. What is the ratio of the Value added (current US$) of Central Europe in 2002 to that in 2005?
Make the answer very short. 0.57. What is the ratio of the Value added (current US$) of Colombia in 2002 to that in 2005?
Keep it short and to the point. 0.66. What is the ratio of the Value added (current US$) in Greece in 2002 to that in 2005?
Provide a short and direct response. 0.71. What is the ratio of the Value added (current US$) of Vanuatu in 2002 to that in 2005?
Provide a succinct answer. 0.74. What is the ratio of the Value added (current US$) in Central Europe in 2002 to that in 2006?
Your answer should be compact. 0.5. What is the ratio of the Value added (current US$) of Colombia in 2002 to that in 2006?
Provide a succinct answer. 0.59. What is the ratio of the Value added (current US$) in Greece in 2002 to that in 2006?
Provide a short and direct response. 0.65. What is the ratio of the Value added (current US$) of Vanuatu in 2002 to that in 2006?
Keep it short and to the point. 0.7. What is the ratio of the Value added (current US$) of Central Europe in 2003 to that in 2004?
Provide a short and direct response. 0.8. What is the ratio of the Value added (current US$) of Colombia in 2003 to that in 2004?
Your response must be concise. 0.8. What is the ratio of the Value added (current US$) of Greece in 2003 to that in 2004?
Your answer should be compact. 0.88. What is the ratio of the Value added (current US$) of Vanuatu in 2003 to that in 2004?
Keep it short and to the point. 0.88. What is the ratio of the Value added (current US$) in Central Europe in 2003 to that in 2005?
Ensure brevity in your answer.  0.7. What is the ratio of the Value added (current US$) in Colombia in 2003 to that in 2005?
Offer a very short reply. 0.65. What is the ratio of the Value added (current US$) in Greece in 2003 to that in 2005?
Give a very brief answer. 0.87. What is the ratio of the Value added (current US$) of Vanuatu in 2003 to that in 2005?
Give a very brief answer. 0.86. What is the ratio of the Value added (current US$) in Central Europe in 2003 to that in 2006?
Offer a very short reply. 0.61. What is the ratio of the Value added (current US$) in Colombia in 2003 to that in 2006?
Your answer should be very brief. 0.58. What is the ratio of the Value added (current US$) in Greece in 2003 to that in 2006?
Your response must be concise. 0.8. What is the ratio of the Value added (current US$) of Vanuatu in 2003 to that in 2006?
Provide a succinct answer. 0.81. What is the ratio of the Value added (current US$) of Central Europe in 2004 to that in 2005?
Offer a very short reply. 0.88. What is the ratio of the Value added (current US$) in Colombia in 2004 to that in 2005?
Provide a succinct answer. 0.81. What is the ratio of the Value added (current US$) of Greece in 2004 to that in 2005?
Your answer should be very brief. 0.99. What is the ratio of the Value added (current US$) in Vanuatu in 2004 to that in 2005?
Make the answer very short. 0.98. What is the ratio of the Value added (current US$) in Central Europe in 2004 to that in 2006?
Offer a terse response. 0.76. What is the ratio of the Value added (current US$) in Colombia in 2004 to that in 2006?
Give a very brief answer. 0.73. What is the ratio of the Value added (current US$) of Greece in 2004 to that in 2006?
Offer a very short reply. 0.91. What is the ratio of the Value added (current US$) in Vanuatu in 2004 to that in 2006?
Your answer should be compact. 0.93. What is the ratio of the Value added (current US$) in Central Europe in 2005 to that in 2006?
Offer a terse response. 0.87. What is the ratio of the Value added (current US$) in Colombia in 2005 to that in 2006?
Your response must be concise. 0.89. What is the ratio of the Value added (current US$) in Greece in 2005 to that in 2006?
Offer a very short reply. 0.92. What is the ratio of the Value added (current US$) of Vanuatu in 2005 to that in 2006?
Your answer should be very brief. 0.95. What is the difference between the highest and the second highest Value added (current US$) of Central Europe?
Make the answer very short. 2.40e+1. What is the difference between the highest and the second highest Value added (current US$) in Colombia?
Keep it short and to the point. 2.45e+09. What is the difference between the highest and the second highest Value added (current US$) of Greece?
Provide a succinct answer. 1.84e+09. What is the difference between the highest and the second highest Value added (current US$) in Vanuatu?
Your response must be concise. 8.68e+05. What is the difference between the highest and the lowest Value added (current US$) of Central Europe?
Your response must be concise. 1.08e+11. What is the difference between the highest and the lowest Value added (current US$) of Colombia?
Give a very brief answer. 9.69e+09. What is the difference between the highest and the lowest Value added (current US$) in Greece?
Make the answer very short. 1.08e+1. What is the difference between the highest and the lowest Value added (current US$) of Vanuatu?
Keep it short and to the point. 4.83e+06. 